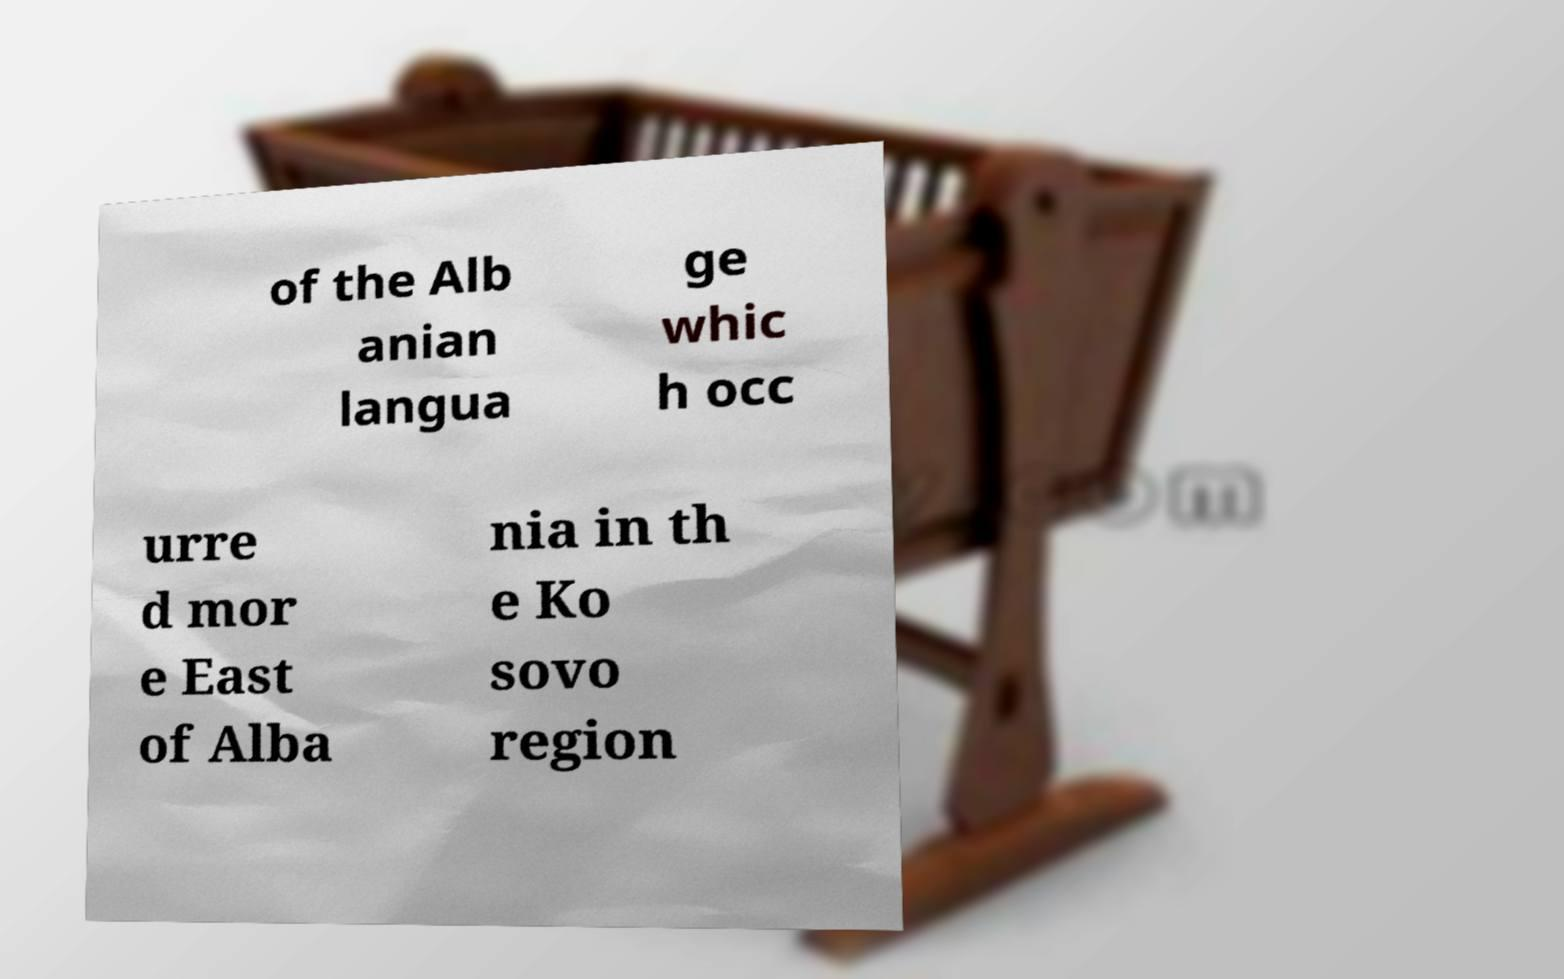There's text embedded in this image that I need extracted. Can you transcribe it verbatim? of the Alb anian langua ge whic h occ urre d mor e East of Alba nia in th e Ko sovo region 